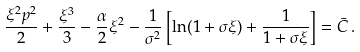<formula> <loc_0><loc_0><loc_500><loc_500>\frac { \xi ^ { 2 } p ^ { 2 } } { 2 } + \frac { \xi ^ { 3 } } { 3 } - \frac { \alpha } { 2 } \xi ^ { 2 } - \frac { 1 } { \sigma ^ { 2 } } \left [ \ln ( 1 + \sigma \xi ) + \frac { 1 } { 1 + \sigma \xi } \right ] = { \bar { C } } \, .</formula> 